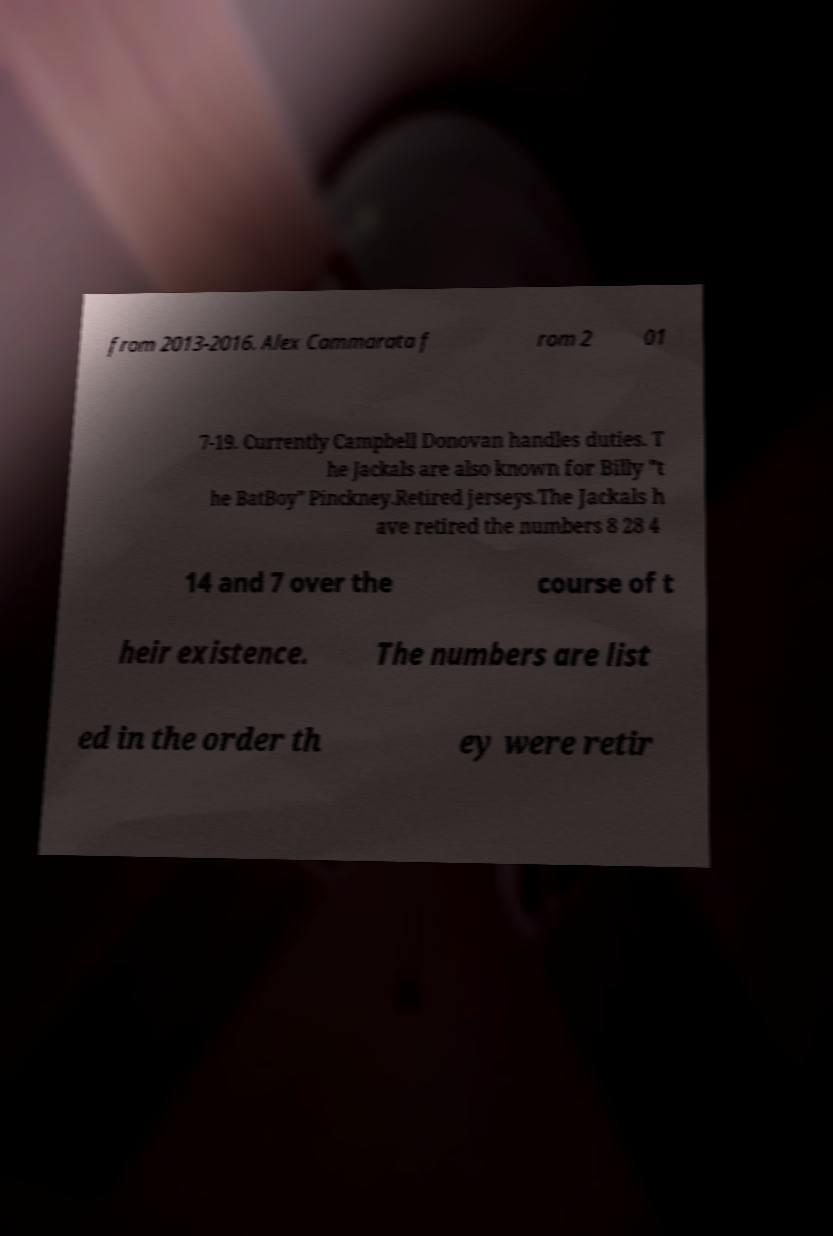For documentation purposes, I need the text within this image transcribed. Could you provide that? from 2013-2016. Alex Cammarata f rom 2 01 7-19. Currently Campbell Donovan handles duties. T he Jackals are also known for Billy "t he BatBoy" Pinckney.Retired jerseys.The Jackals h ave retired the numbers 8 28 4 14 and 7 over the course of t heir existence. The numbers are list ed in the order th ey were retir 